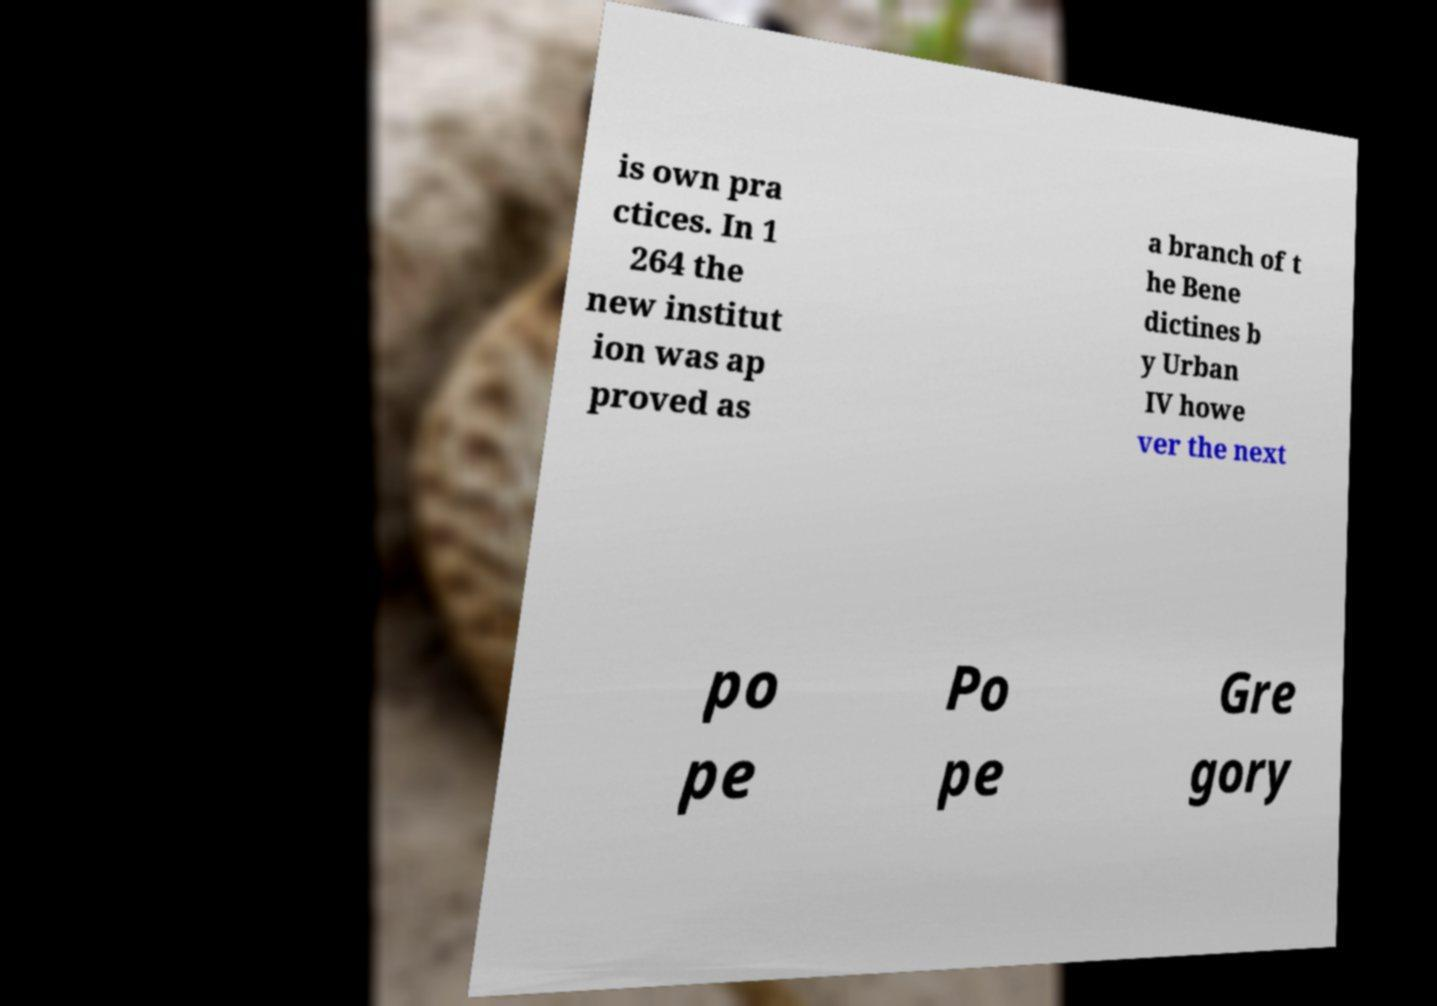I need the written content from this picture converted into text. Can you do that? is own pra ctices. In 1 264 the new institut ion was ap proved as a branch of t he Bene dictines b y Urban IV howe ver the next po pe Po pe Gre gory 